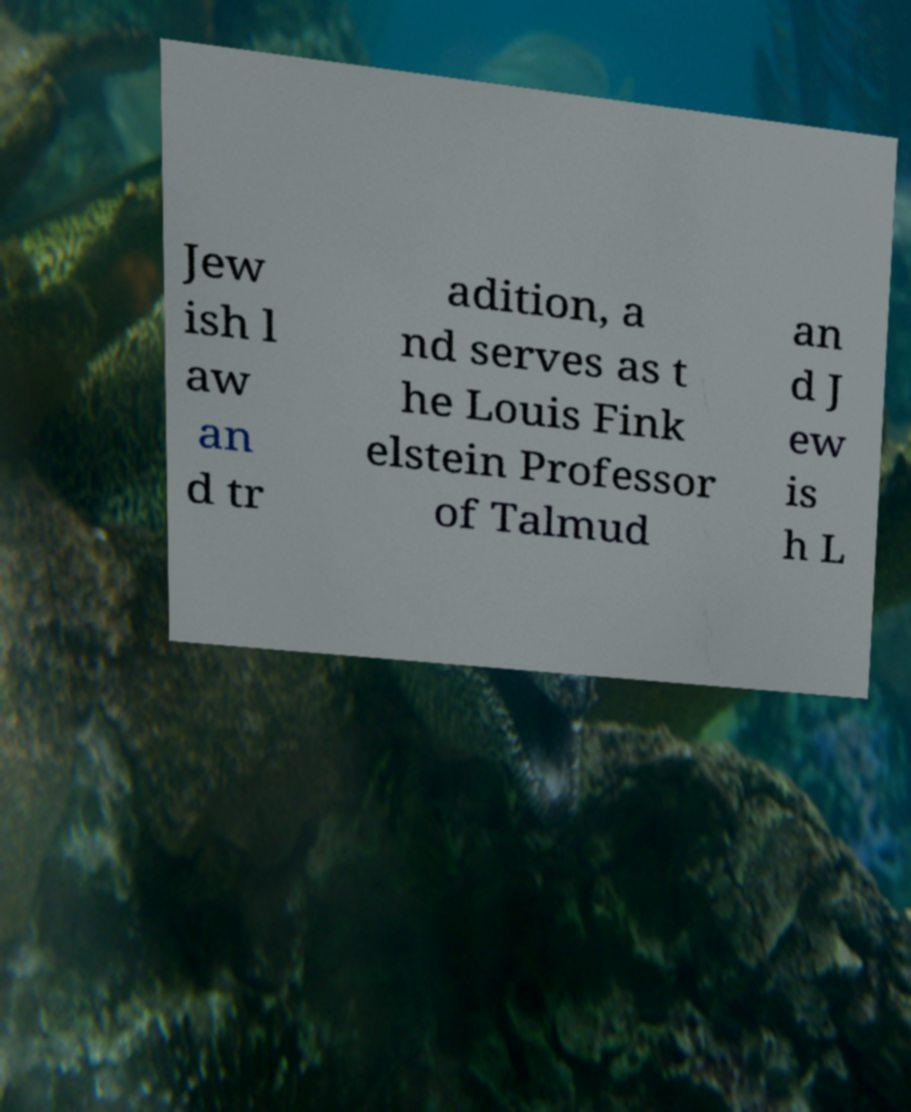Could you assist in decoding the text presented in this image and type it out clearly? Jew ish l aw an d tr adition, a nd serves as t he Louis Fink elstein Professor of Talmud an d J ew is h L 